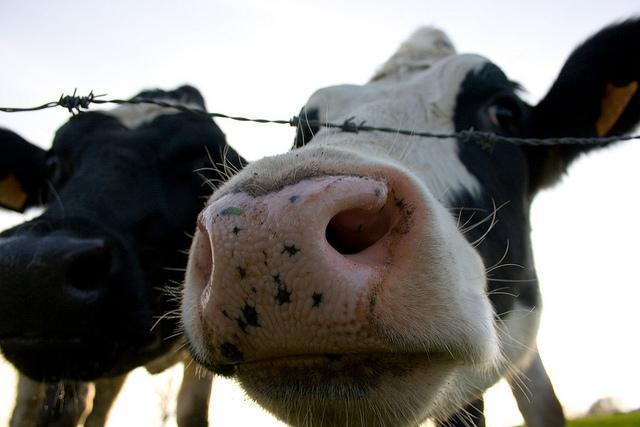How many cows can be seen?
Give a very brief answer. 2. 